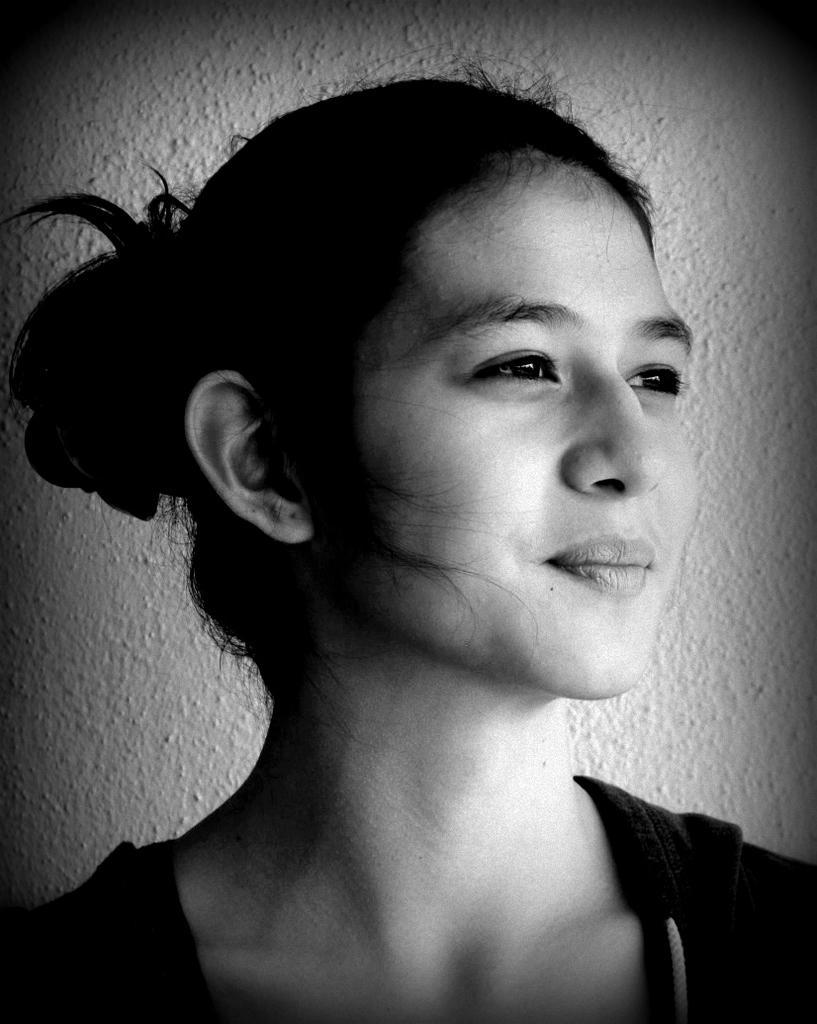Describe this image in one or two sentences. This is the picture of a black and white image where we can see a person and in the background, we can see the wall. 